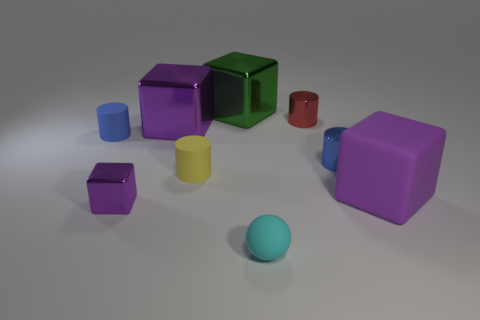There is a tiny rubber object behind the rubber cylinder on the right side of the blue cylinder behind the tiny blue metal cylinder; what is its shape? The tiny rubber object in question appears to be spherical in shape. 